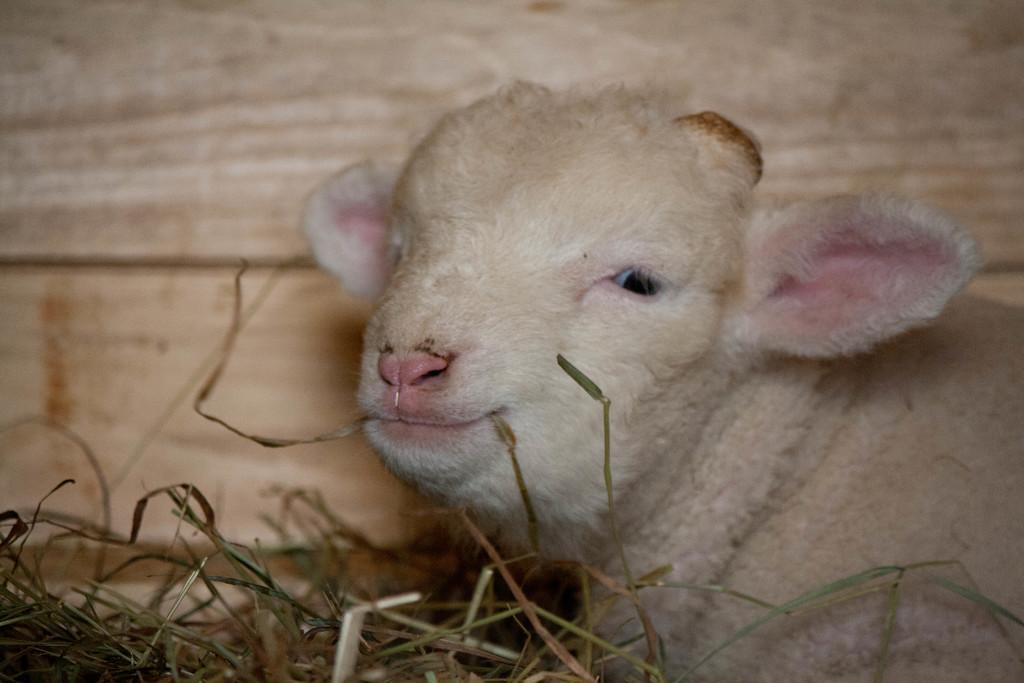Describe this image in one or two sentences. In the image we can see there is a baby goat sitting on the ground and there are dry grass on the ground. 